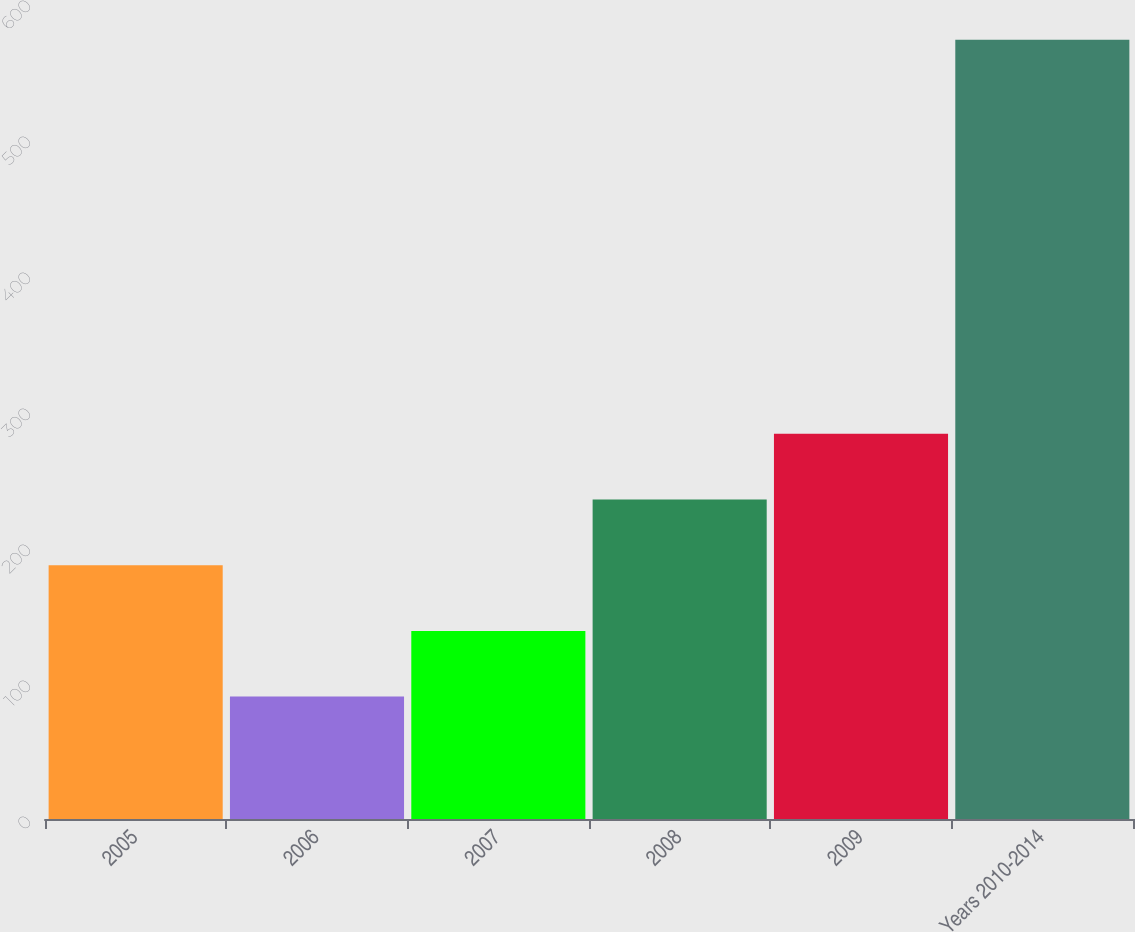Convert chart to OTSL. <chart><loc_0><loc_0><loc_500><loc_500><bar_chart><fcel>2005<fcel>2006<fcel>2007<fcel>2008<fcel>2009<fcel>Years 2010-2014<nl><fcel>186.6<fcel>90<fcel>138.3<fcel>234.9<fcel>283.2<fcel>573<nl></chart> 